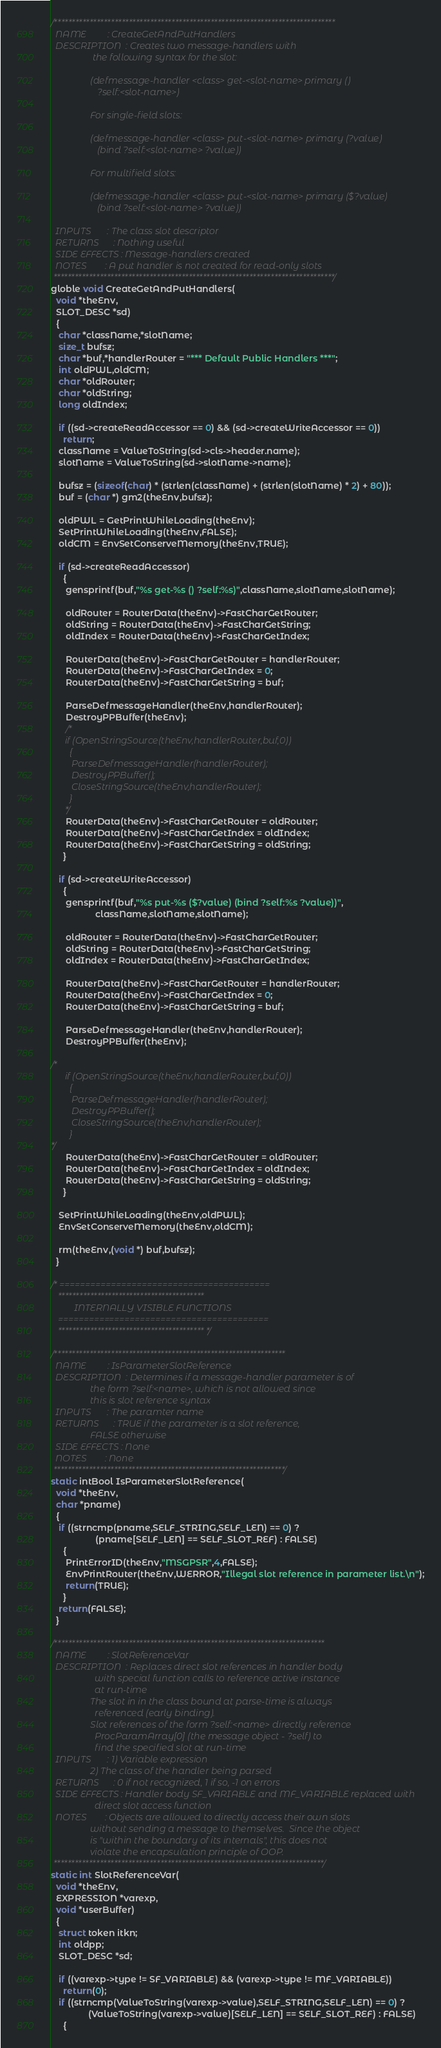<code> <loc_0><loc_0><loc_500><loc_500><_C_>
/*******************************************************************************
  NAME         : CreateGetAndPutHandlers
  DESCRIPTION  : Creates two message-handlers with
                  the following syntax for the slot:

                 (defmessage-handler <class> get-<slot-name> primary ()
                    ?self:<slot-name>)

                 For single-field slots:

                 (defmessage-handler <class> put-<slot-name> primary (?value)
                    (bind ?self:<slot-name> ?value))

                 For multifield slots:

                 (defmessage-handler <class> put-<slot-name> primary ($?value)
                    (bind ?self:<slot-name> ?value))

  INPUTS       : The class slot descriptor
  RETURNS      : Nothing useful
  SIDE EFFECTS : Message-handlers created
  NOTES        : A put handler is not created for read-only slots
 *******************************************************************************/
globle void CreateGetAndPutHandlers(
  void *theEnv,
  SLOT_DESC *sd)
  {
   char *className,*slotName;
   size_t bufsz;
   char *buf,*handlerRouter = "*** Default Public Handlers ***";
   int oldPWL,oldCM;
   char *oldRouter;
   char *oldString;
   long oldIndex;

   if ((sd->createReadAccessor == 0) && (sd->createWriteAccessor == 0))
     return;
   className = ValueToString(sd->cls->header.name);
   slotName = ValueToString(sd->slotName->name);

   bufsz = (sizeof(char) * (strlen(className) + (strlen(slotName) * 2) + 80));
   buf = (char *) gm2(theEnv,bufsz);

   oldPWL = GetPrintWhileLoading(theEnv);
   SetPrintWhileLoading(theEnv,FALSE);
   oldCM = EnvSetConserveMemory(theEnv,TRUE);

   if (sd->createReadAccessor)
     {
      gensprintf(buf,"%s get-%s () ?self:%s)",className,slotName,slotName);
      
      oldRouter = RouterData(theEnv)->FastCharGetRouter;
      oldString = RouterData(theEnv)->FastCharGetString;
      oldIndex = RouterData(theEnv)->FastCharGetIndex;
   
      RouterData(theEnv)->FastCharGetRouter = handlerRouter;
      RouterData(theEnv)->FastCharGetIndex = 0;
      RouterData(theEnv)->FastCharGetString = buf;
      
      ParseDefmessageHandler(theEnv,handlerRouter);
      DestroyPPBuffer(theEnv);
      /*
      if (OpenStringSource(theEnv,handlerRouter,buf,0))
        {
         ParseDefmessageHandler(handlerRouter);
         DestroyPPBuffer();
         CloseStringSource(theEnv,handlerRouter);
        }
      */
      RouterData(theEnv)->FastCharGetRouter = oldRouter;
      RouterData(theEnv)->FastCharGetIndex = oldIndex;
      RouterData(theEnv)->FastCharGetString = oldString;
     }

   if (sd->createWriteAccessor)
     {
      gensprintf(buf,"%s put-%s ($?value) (bind ?self:%s ?value))",
                  className,slotName,slotName);
                  
      oldRouter = RouterData(theEnv)->FastCharGetRouter;
      oldString = RouterData(theEnv)->FastCharGetString;
      oldIndex = RouterData(theEnv)->FastCharGetIndex;
   
      RouterData(theEnv)->FastCharGetRouter = handlerRouter;
      RouterData(theEnv)->FastCharGetIndex = 0;
      RouterData(theEnv)->FastCharGetString = buf;
      
      ParseDefmessageHandler(theEnv,handlerRouter);
      DestroyPPBuffer(theEnv);

/*     
      if (OpenStringSource(theEnv,handlerRouter,buf,0))
        {
         ParseDefmessageHandler(handlerRouter);
         DestroyPPBuffer();
         CloseStringSource(theEnv,handlerRouter);
        }
*/        
      RouterData(theEnv)->FastCharGetRouter = oldRouter;
      RouterData(theEnv)->FastCharGetIndex = oldIndex;
      RouterData(theEnv)->FastCharGetString = oldString;
     }

   SetPrintWhileLoading(theEnv,oldPWL);
   EnvSetConserveMemory(theEnv,oldCM);

   rm(theEnv,(void *) buf,bufsz);
  }

/* =========================================
   *****************************************
          INTERNALLY VISIBLE FUNCTIONS
   =========================================
   ***************************************** */

/*****************************************************************
  NAME         : IsParameterSlotReference
  DESCRIPTION  : Determines if a message-handler parameter is of
                 the form ?self:<name>, which is not allowed since
                 this is slot reference syntax
  INPUTS       : The paramter name
  RETURNS      : TRUE if the parameter is a slot reference,
                 FALSE otherwise
  SIDE EFFECTS : None
  NOTES        : None
 *****************************************************************/
static intBool IsParameterSlotReference(
  void *theEnv,
  char *pname)
  {
   if ((strncmp(pname,SELF_STRING,SELF_LEN) == 0) ?
                  (pname[SELF_LEN] == SELF_SLOT_REF) : FALSE)
     {
      PrintErrorID(theEnv,"MSGPSR",4,FALSE);
      EnvPrintRouter(theEnv,WERROR,"Illegal slot reference in parameter list.\n");
      return(TRUE);
     }
   return(FALSE);
  }

/****************************************************************************
  NAME         : SlotReferenceVar
  DESCRIPTION  : Replaces direct slot references in handler body
                   with special function calls to reference active instance
                   at run-time
                 The slot in in the class bound at parse-time is always
                   referenced (early binding).
                 Slot references of the form ?self:<name> directly reference
                   ProcParamArray[0] (the message object - ?self) to
                   find the specified slot at run-time
  INPUTS       : 1) Variable expression
                 2) The class of the handler being parsed
  RETURNS      : 0 if not recognized, 1 if so, -1 on errors
  SIDE EFFECTS : Handler body SF_VARIABLE and MF_VARIABLE replaced with
                   direct slot access function
  NOTES        : Objects are allowed to directly access their own slots
                 without sending a message to themselves.  Since the object
                 is "within the boundary of its internals", this does not
                 violate the encapsulation principle of OOP.
 ****************************************************************************/
static int SlotReferenceVar(
  void *theEnv,
  EXPRESSION *varexp,
  void *userBuffer)
  {
   struct token itkn;
   int oldpp;
   SLOT_DESC *sd;

   if ((varexp->type != SF_VARIABLE) && (varexp->type != MF_VARIABLE))
     return(0);
   if ((strncmp(ValueToString(varexp->value),SELF_STRING,SELF_LEN) == 0) ?
               (ValueToString(varexp->value)[SELF_LEN] == SELF_SLOT_REF) : FALSE)
     {</code> 